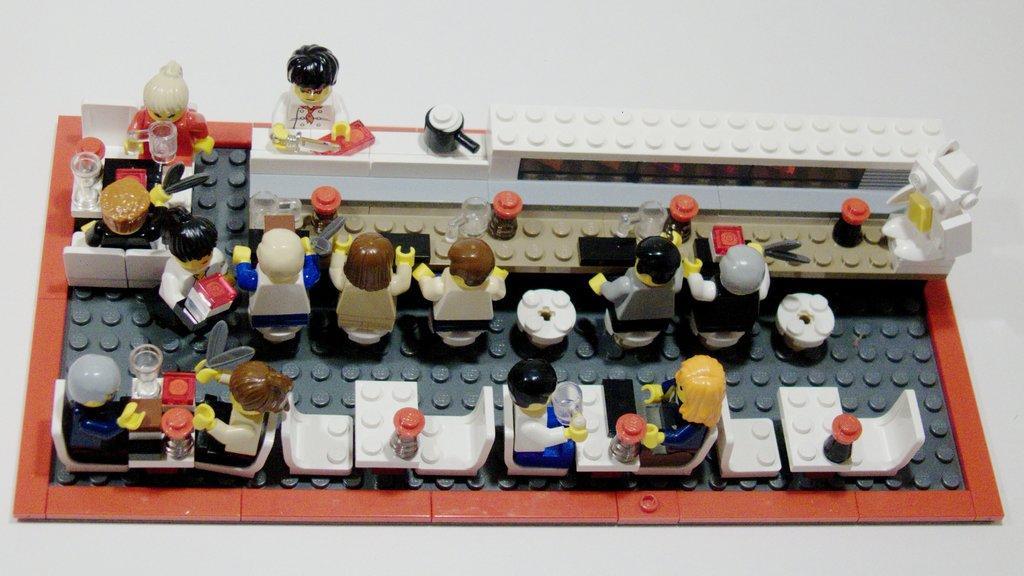Please provide a concise description of this image. In this image we can see group of dolls placed on the surface. In the background ,we can see Lego toys,some jars and mugs. 